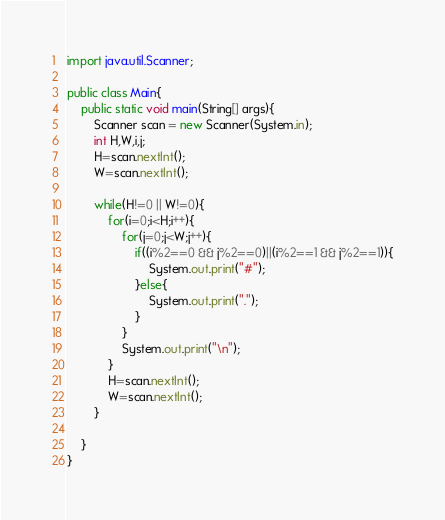Convert code to text. <code><loc_0><loc_0><loc_500><loc_500><_Java_>import java.util.Scanner;

public class Main{
    public static void main(String[] args){
        Scanner scan = new Scanner(System.in);
        int H,W,i,j;
        H=scan.nextInt();
        W=scan.nextInt();

        while(H!=0 || W!=0){
            for(i=0;i<H;i++){
                for(j=0;j<W;j++){
                    if((i%2==0 && j%2==0)||(i%2==1 && j%2==1)){
                        System.out.print("#");
                    }else{
                        System.out.print(".");
                    }
                }
                System.out.print("\n");
            }
            H=scan.nextInt();
            W=scan.nextInt();
        }

    }
}
</code> 